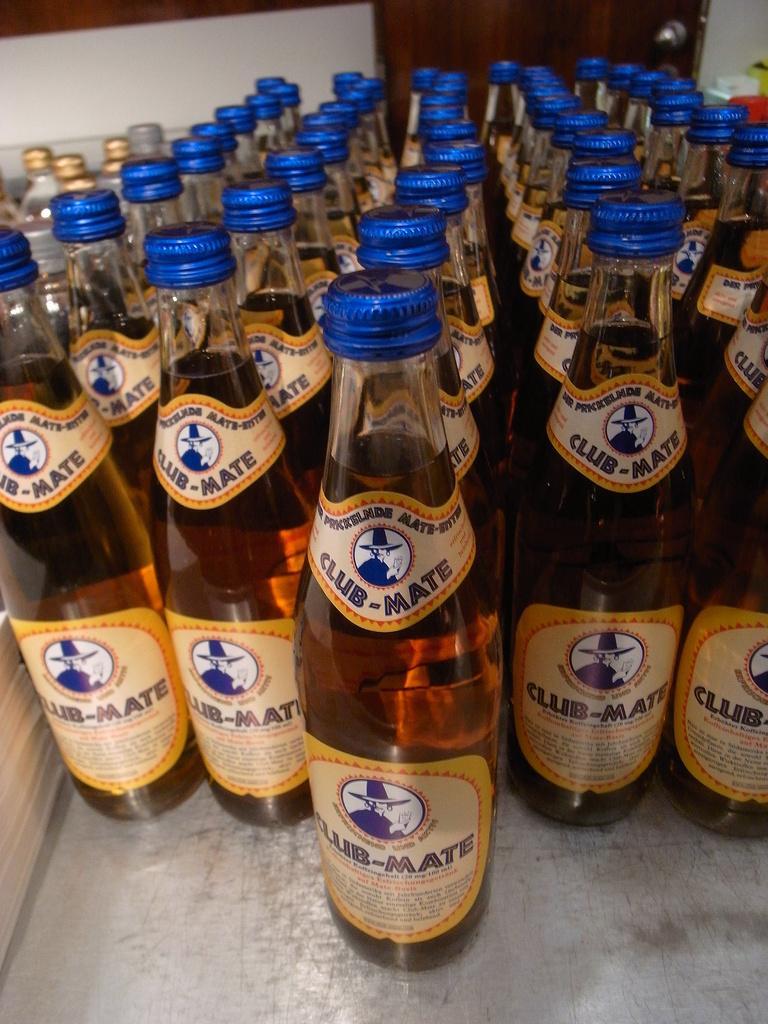How would you summarize this image in a sentence or two? In this a picture we can see a number of bottles with a blue cap, in this bottles there was a liquid and on the bottle we can see a sticker ,on that label we can see a words club mate ,on that sticker we can also see a person with a cap. 